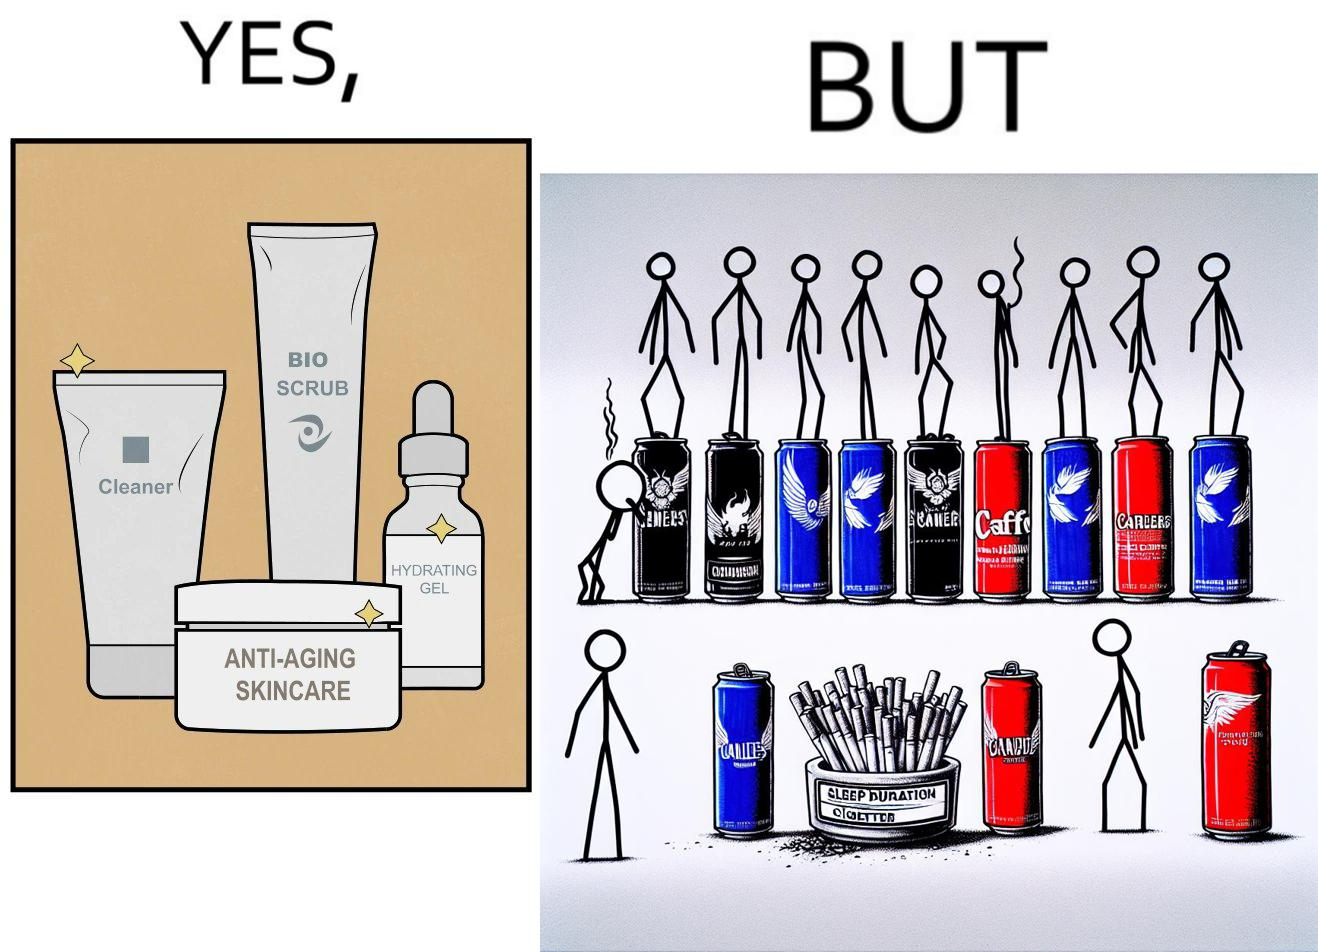Describe the content of this image. This image is ironic as on the one hand, the presumed person is into skincare and wants to do the best for their skin, which is good, but on the other hand, they are involved in unhealthy habits that will damage their skin like smoking, caffeine and inadequate sleep. 